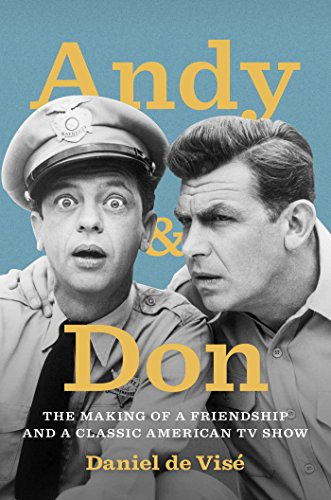Who wrote this book? The book 'Andy and Don' was authored by Daniel de Visé, an accomplished writer with a flair for exploring iconic television partnerships. 